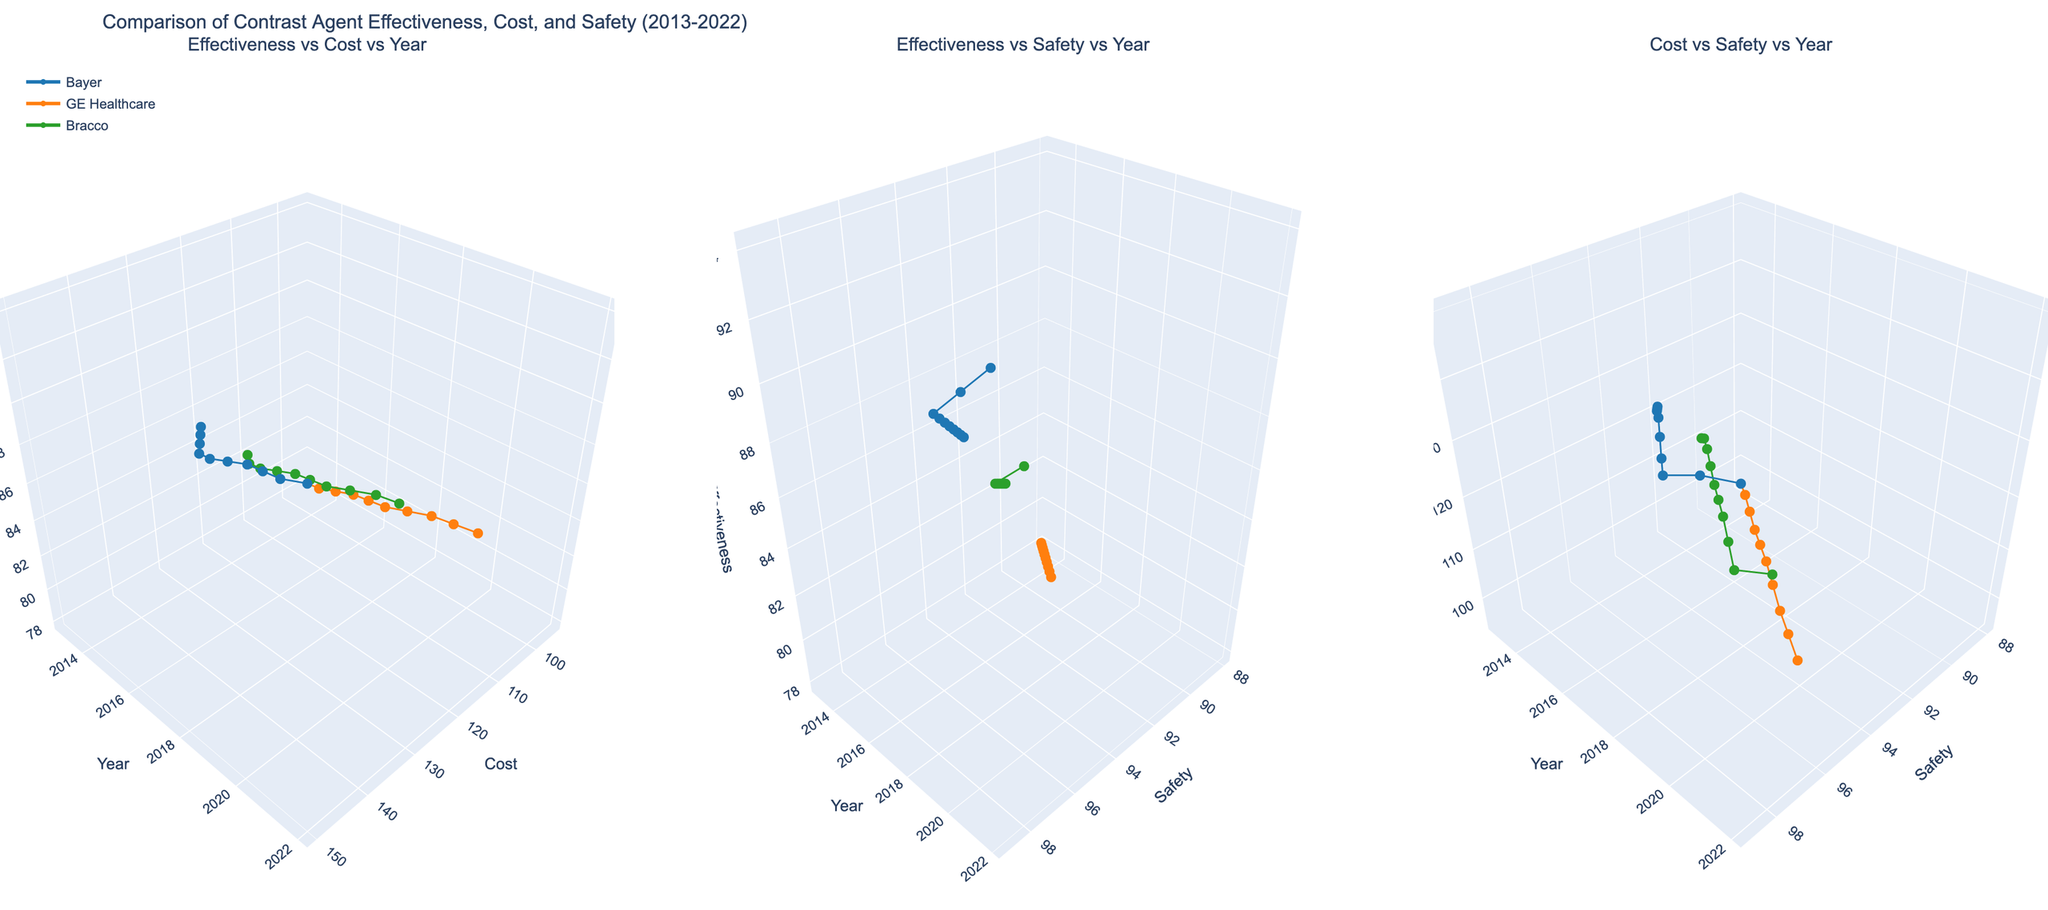What is the title of the figure? The title is typically displayed at the top of the figure which summarizes the content.
Answer: Comparison of Contrast Agent Effectiveness, Cost, and Safety (2013-2022) Which manufacturer has the lowest effectiveness in 2013 according to the first subplot? In the first subplot (Effectiveness vs Cost vs Year), look at the effectiveness values for each manufacturer in 2013. GE Healthcare’s Omniscan has the lowest effectiveness at 78.
Answer: GE Healthcare How does the cost of Bayer's Gadovist change over the years in the first subplot? Track the line marked by Bayer in the first subplot along the cost axis (X-axis) from 2013 to 2022. The cost steadily increases from 120 in 2013 to 150 in 2022.
Answer: It increases Which manufacturer shows the greatest improvement in effectiveness over the decade considering the second subplot? In the second subplot (Effectiveness vs Safety vs Year), compare the starting and ending effectiveness values for each manufacturer over the years 2013 to 2022. Bayer’s Gadovist starts at 85 and ends at 94, showing the largest improvement.
Answer: Bayer What is the safety profile of Bracco's ProHance in 2020 from the second subplot? Locate Bracco in the second subplot for the year 2020 and read off the safety value. The safety value for ProHance in 2020 is 97.
Answer: 97 Compare the cost of GE Healthcare's Omniscan to Bracco's ProHance in 2022 as seen in the third subplot. Which is higher? In the third subplot (Cost vs Safety vs Year), look for the year 2022 and compare the cost values for GE Healthcare's Omniscan and Bracco's ProHance. Omniscan's cost is 118 while ProHance's cost is 135.
Answer: Bracco's ProHance Which manufacturer had a steeper increase in safety from 2013 to 2022 according to the second subplot? Observe the trajectory of safety values from 2013 to 2022 in the second subplot for each manufacturer. Bracco's ProHance shows a steep increase in safety from 90 in 2013 to 98 in 2022.
Answer: Bracco What can you infer about the relationship between cost and safety for all manufacturers in the third subplot? In the third subplot, observe the general trend of cost versus safety values over the years for all manufacturers. As the safety value increases, the cost also tends to increase for all manufacturers.
Answer: Cost increases with safety 